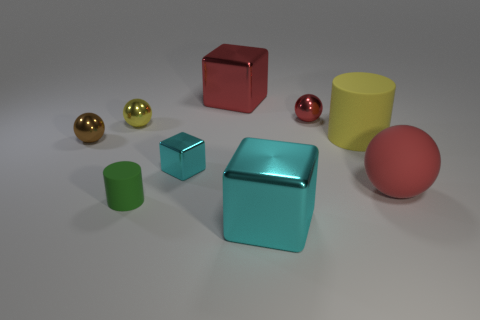Subtract 1 spheres. How many spheres are left? 3 Add 1 cyan shiny cubes. How many objects exist? 10 Subtract all balls. How many objects are left? 5 Subtract all large red metallic cubes. Subtract all tiny red metallic balls. How many objects are left? 7 Add 9 large cyan objects. How many large cyan objects are left? 10 Add 4 green things. How many green things exist? 5 Subtract 0 green balls. How many objects are left? 9 